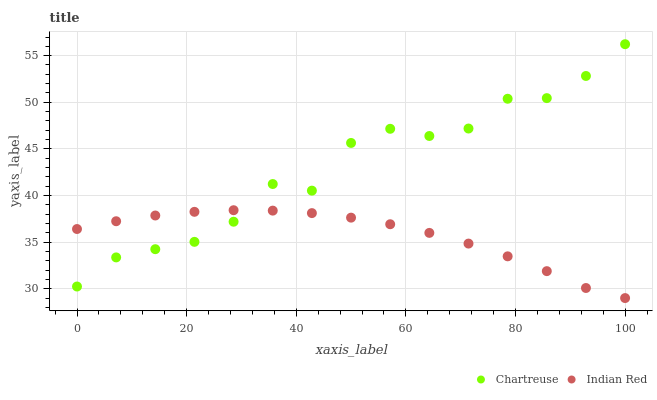Does Indian Red have the minimum area under the curve?
Answer yes or no. Yes. Does Chartreuse have the maximum area under the curve?
Answer yes or no. Yes. Does Indian Red have the maximum area under the curve?
Answer yes or no. No. Is Indian Red the smoothest?
Answer yes or no. Yes. Is Chartreuse the roughest?
Answer yes or no. Yes. Is Indian Red the roughest?
Answer yes or no. No. Does Indian Red have the lowest value?
Answer yes or no. Yes. Does Chartreuse have the highest value?
Answer yes or no. Yes. Does Indian Red have the highest value?
Answer yes or no. No. Does Chartreuse intersect Indian Red?
Answer yes or no. Yes. Is Chartreuse less than Indian Red?
Answer yes or no. No. Is Chartreuse greater than Indian Red?
Answer yes or no. No. 